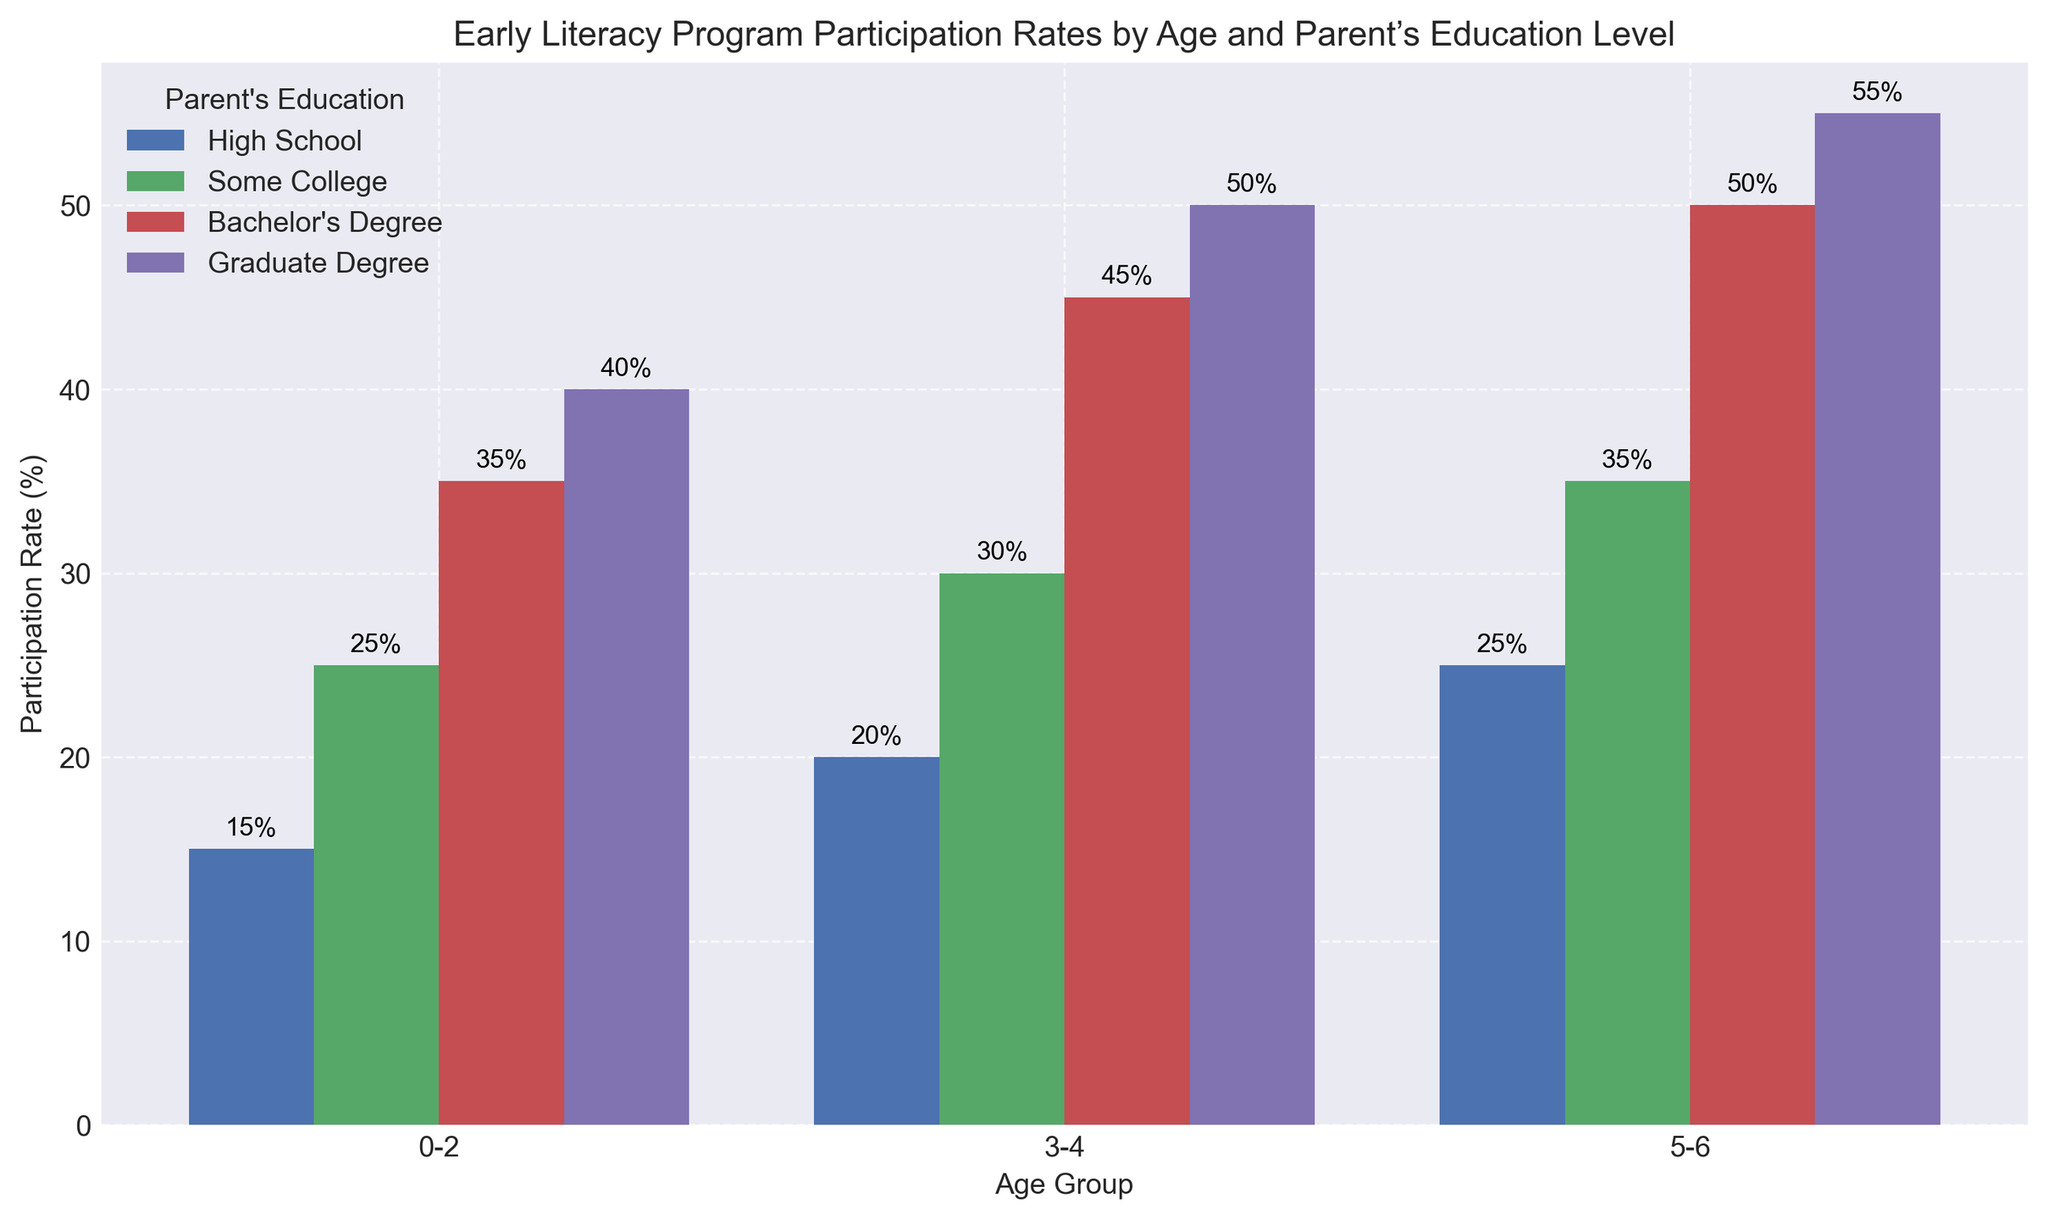What's the overall highest participation rate displayed in the figure? The highest participation rate is observed by looking at the tallest bars. The tallest bar corresponds to the Graduate Degree parent education level for the 5-6 age group, which has a rate of 55%.
Answer: 55% Which age group shows the most significant increase in participation rates when moving from High School education to Graduate Degree education? To answer this, compare the heights of the bars for each age group, looking at the difference in participation rates between High School and Graduate Degree education. The increase is 25% (40% - 15%) for the 0-2 age group, 30% (50% - 20%) for the 3-4 age group, and 30% (55% - 25%) for the 5-6 age group. The 3-4 and 5-6 age groups show the largest increase.
Answer: 3-4 and 5-6 What's the average participation rate for children aged 0-2 across all parent education levels? Add the participation rates for the 0-2 age group (15% + 25% + 35% + 40%) and divide by 4. The sum is 115%, and the average is 115/4 = 28.75%.
Answer: 28.75% How does the participation rate for parents with a Bachelor's Degree differ between the 0-2 age group and the 5-6 age group? For parents with a Bachelor's Degree, the participation rates are 35% for the 0-2 age group and 50% for the 5-6 age group. The difference is 50% - 35% = 15%.
Answer: 15% Which parent education level has the least variation in participation rates across all age groups? To determine this, compare the range of participation rates (maximum - minimum) for each parent education level. High School: 25% - 15% = 10%, Some College: 35% - 25% = 10%, Bachelor's Degree: 50% - 35% = 15%, Graduate Degree: 55% - 40% = 15%. Both High School and Some College have the least variation (10%).
Answer: High School and Some College Among parents with Some College education, which age group has the lowest participation rate? For Some College education level, compare the height of bars for each age group and identify the lowest. The participation rates are 25% for 0-2, 30% for 3-4, and 35% for 5-6. The lowest is 25% for the 0-2 age group.
Answer: 0-2 What is the total participation rate for children aged 5-6 across all parent education levels? Add the participation rates for the 5-6 age group for each parent education level (25% + 35% + 50% + 55%). The sum is 165%.
Answer: 165% What's the difference in participation rate between parents with a Graduate Degree and Some College education for the 3-4 age group? For the 3-4 age group, the participation rates are 50% for Graduate Degree and 30% for Some College. The difference is 50% - 30% = 20%.
Answer: 20% Which combination of age group and parent education level shows the lowest participation rate? By visually inspecting the shortest bars, the lowest participation rate is found for the age group 0-2 with High School education level, which is 15%.
Answer: 0-2, High School 